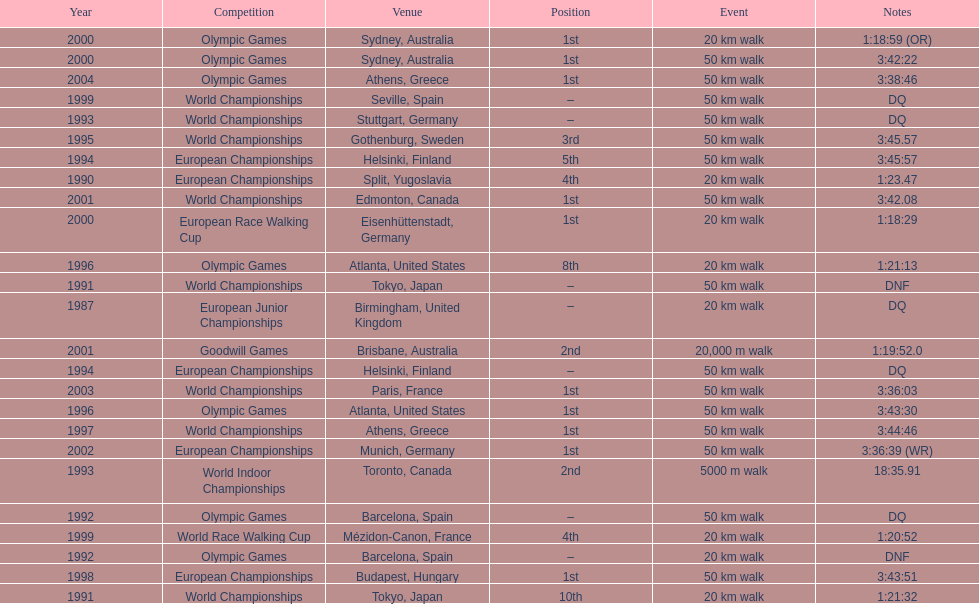How many times did korzeniowski finish above fourth place? 13. 